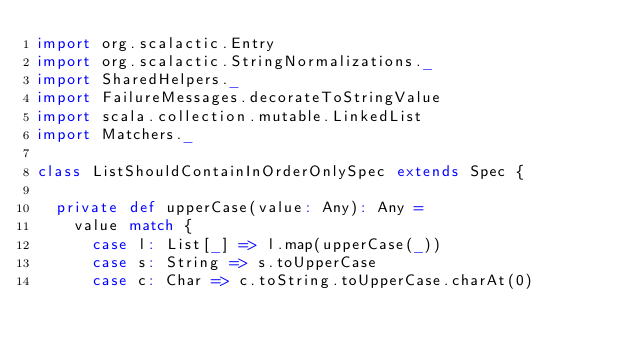Convert code to text. <code><loc_0><loc_0><loc_500><loc_500><_Scala_>import org.scalactic.Entry
import org.scalactic.StringNormalizations._
import SharedHelpers._
import FailureMessages.decorateToStringValue
import scala.collection.mutable.LinkedList
import Matchers._

class ListShouldContainInOrderOnlySpec extends Spec {

  private def upperCase(value: Any): Any = 
    value match {
      case l: List[_] => l.map(upperCase(_))
      case s: String => s.toUpperCase
      case c: Char => c.toString.toUpperCase.charAt(0)</code> 